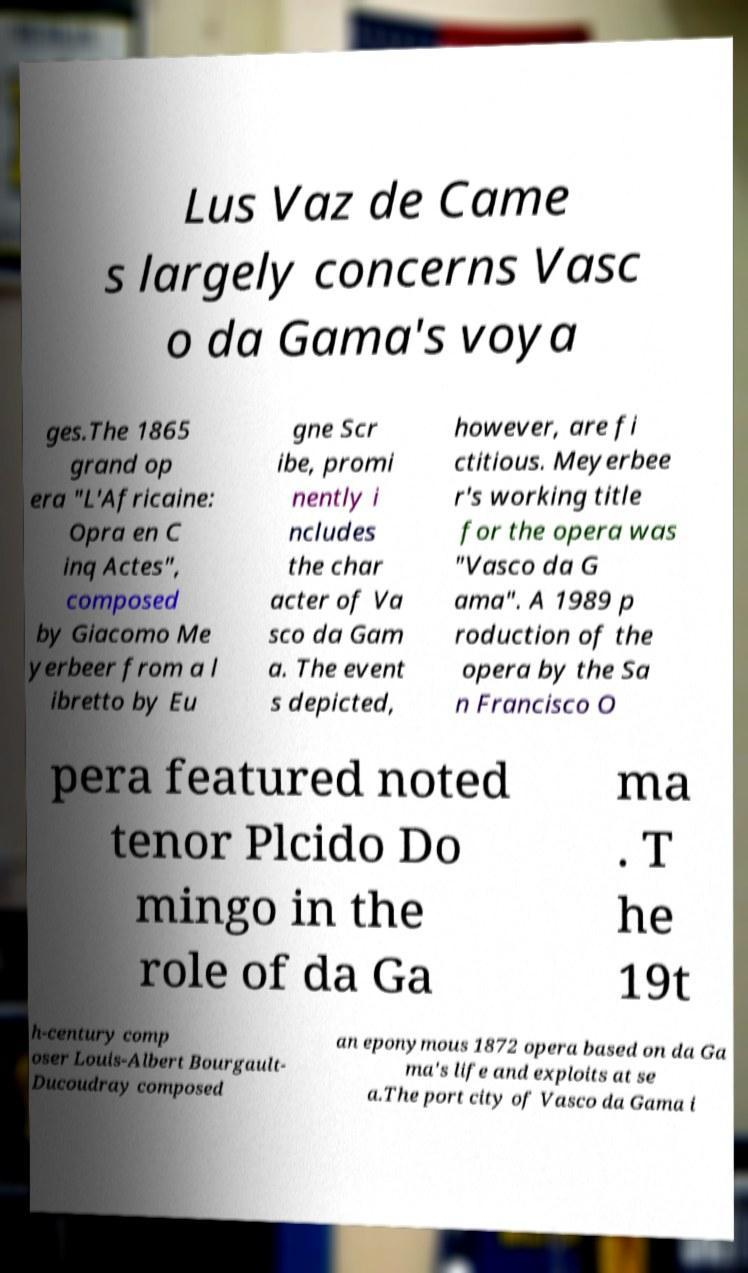Can you accurately transcribe the text from the provided image for me? Lus Vaz de Came s largely concerns Vasc o da Gama's voya ges.The 1865 grand op era "L'Africaine: Opra en C inq Actes", composed by Giacomo Me yerbeer from a l ibretto by Eu gne Scr ibe, promi nently i ncludes the char acter of Va sco da Gam a. The event s depicted, however, are fi ctitious. Meyerbee r's working title for the opera was "Vasco da G ama". A 1989 p roduction of the opera by the Sa n Francisco O pera featured noted tenor Plcido Do mingo in the role of da Ga ma . T he 19t h-century comp oser Louis-Albert Bourgault- Ducoudray composed an eponymous 1872 opera based on da Ga ma's life and exploits at se a.The port city of Vasco da Gama i 